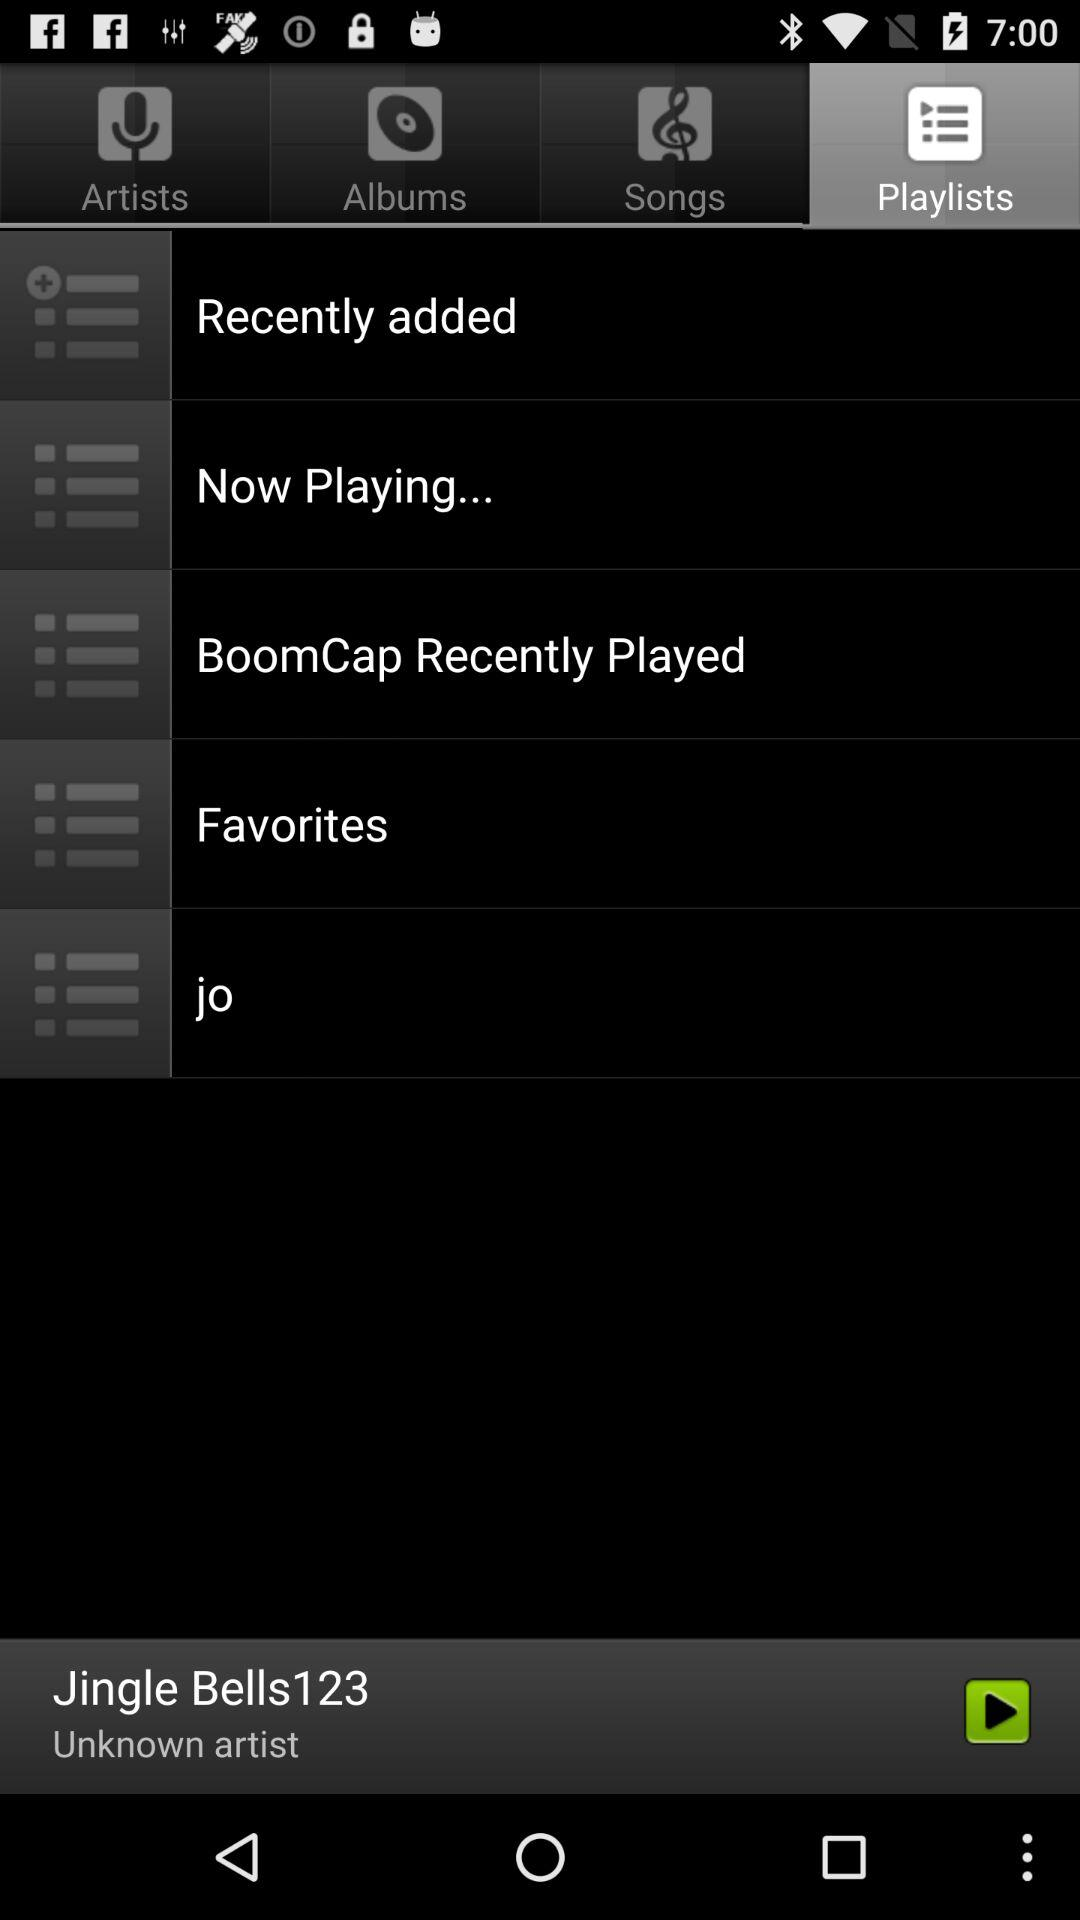What's the current playing track? The currently playing track is "Jingle Bells123". 